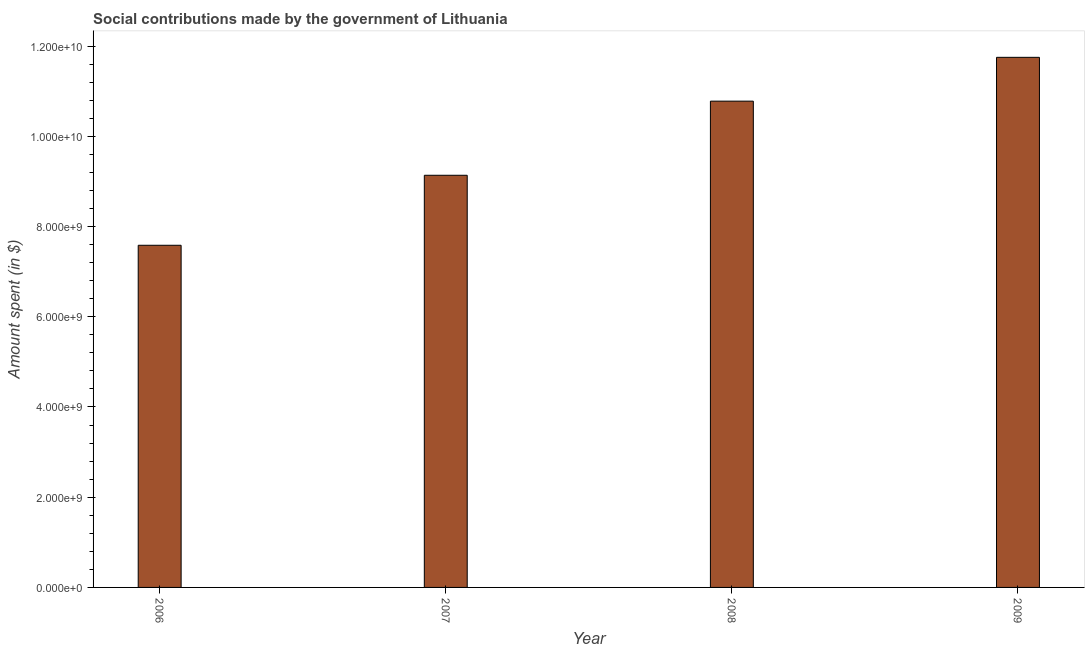Does the graph contain any zero values?
Provide a succinct answer. No. Does the graph contain grids?
Offer a very short reply. No. What is the title of the graph?
Your answer should be compact. Social contributions made by the government of Lithuania. What is the label or title of the Y-axis?
Provide a succinct answer. Amount spent (in $). What is the amount spent in making social contributions in 2009?
Provide a succinct answer. 1.17e+1. Across all years, what is the maximum amount spent in making social contributions?
Offer a terse response. 1.17e+1. Across all years, what is the minimum amount spent in making social contributions?
Provide a short and direct response. 7.58e+09. What is the sum of the amount spent in making social contributions?
Your answer should be very brief. 3.92e+1. What is the difference between the amount spent in making social contributions in 2006 and 2009?
Give a very brief answer. -4.17e+09. What is the average amount spent in making social contributions per year?
Your answer should be very brief. 9.81e+09. What is the median amount spent in making social contributions?
Make the answer very short. 9.96e+09. In how many years, is the amount spent in making social contributions greater than 7200000000 $?
Provide a short and direct response. 4. Do a majority of the years between 2008 and 2007 (inclusive) have amount spent in making social contributions greater than 11600000000 $?
Make the answer very short. No. What is the ratio of the amount spent in making social contributions in 2006 to that in 2009?
Your response must be concise. 0.65. What is the difference between the highest and the second highest amount spent in making social contributions?
Offer a terse response. 9.71e+08. What is the difference between the highest and the lowest amount spent in making social contributions?
Ensure brevity in your answer.  4.17e+09. In how many years, is the amount spent in making social contributions greater than the average amount spent in making social contributions taken over all years?
Provide a succinct answer. 2. What is the difference between two consecutive major ticks on the Y-axis?
Offer a very short reply. 2.00e+09. Are the values on the major ticks of Y-axis written in scientific E-notation?
Your response must be concise. Yes. What is the Amount spent (in $) of 2006?
Offer a very short reply. 7.58e+09. What is the Amount spent (in $) of 2007?
Give a very brief answer. 9.14e+09. What is the Amount spent (in $) of 2008?
Give a very brief answer. 1.08e+1. What is the Amount spent (in $) in 2009?
Make the answer very short. 1.17e+1. What is the difference between the Amount spent (in $) in 2006 and 2007?
Offer a very short reply. -1.55e+09. What is the difference between the Amount spent (in $) in 2006 and 2008?
Provide a short and direct response. -3.19e+09. What is the difference between the Amount spent (in $) in 2006 and 2009?
Your answer should be compact. -4.17e+09. What is the difference between the Amount spent (in $) in 2007 and 2008?
Your answer should be compact. -1.64e+09. What is the difference between the Amount spent (in $) in 2007 and 2009?
Make the answer very short. -2.61e+09. What is the difference between the Amount spent (in $) in 2008 and 2009?
Ensure brevity in your answer.  -9.71e+08. What is the ratio of the Amount spent (in $) in 2006 to that in 2007?
Keep it short and to the point. 0.83. What is the ratio of the Amount spent (in $) in 2006 to that in 2008?
Provide a short and direct response. 0.7. What is the ratio of the Amount spent (in $) in 2006 to that in 2009?
Make the answer very short. 0.65. What is the ratio of the Amount spent (in $) in 2007 to that in 2008?
Offer a very short reply. 0.85. What is the ratio of the Amount spent (in $) in 2007 to that in 2009?
Provide a succinct answer. 0.78. What is the ratio of the Amount spent (in $) in 2008 to that in 2009?
Your answer should be very brief. 0.92. 